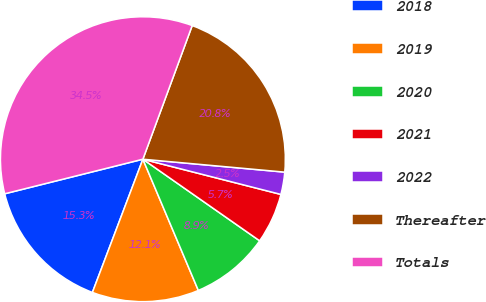Convert chart. <chart><loc_0><loc_0><loc_500><loc_500><pie_chart><fcel>2018<fcel>2019<fcel>2020<fcel>2021<fcel>2022<fcel>Thereafter<fcel>Totals<nl><fcel>15.33%<fcel>12.13%<fcel>8.93%<fcel>5.73%<fcel>2.53%<fcel>20.82%<fcel>34.53%<nl></chart> 